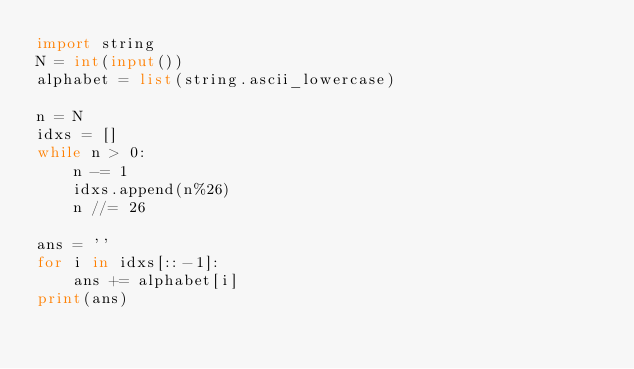Convert code to text. <code><loc_0><loc_0><loc_500><loc_500><_Python_>import string
N = int(input())
alphabet = list(string.ascii_lowercase)

n = N
idxs = []
while n > 0:
    n -= 1
    idxs.append(n%26)
    n //= 26

ans = ''
for i in idxs[::-1]:
    ans += alphabet[i]
print(ans)</code> 